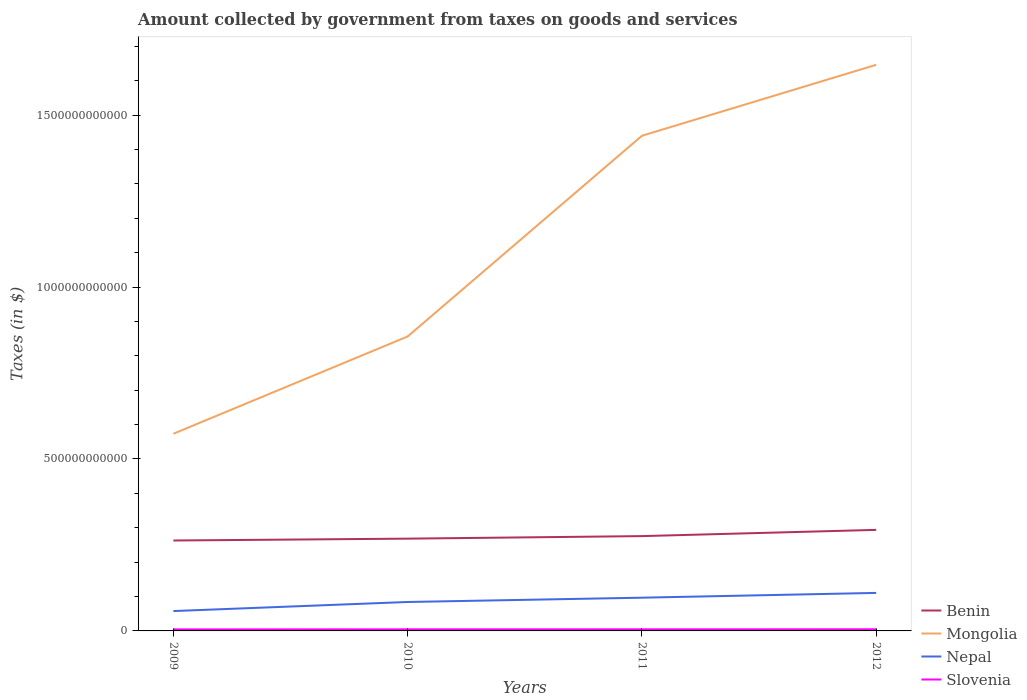Across all years, what is the maximum amount collected by government from taxes on goods and services in Benin?
Your response must be concise. 2.63e+11. What is the total amount collected by government from taxes on goods and services in Nepal in the graph?
Your response must be concise. -2.64e+1. What is the difference between the highest and the second highest amount collected by government from taxes on goods and services in Benin?
Make the answer very short. 3.09e+1. How many lines are there?
Ensure brevity in your answer.  4. What is the difference between two consecutive major ticks on the Y-axis?
Ensure brevity in your answer.  5.00e+11. Does the graph contain grids?
Your response must be concise. No. How many legend labels are there?
Ensure brevity in your answer.  4. What is the title of the graph?
Ensure brevity in your answer.  Amount collected by government from taxes on goods and services. What is the label or title of the Y-axis?
Your answer should be very brief. Taxes (in $). What is the Taxes (in $) in Benin in 2009?
Offer a very short reply. 2.63e+11. What is the Taxes (in $) of Mongolia in 2009?
Make the answer very short. 5.73e+11. What is the Taxes (in $) of Nepal in 2009?
Provide a short and direct response. 5.78e+1. What is the Taxes (in $) of Slovenia in 2009?
Your response must be concise. 4.54e+09. What is the Taxes (in $) in Benin in 2010?
Offer a very short reply. 2.68e+11. What is the Taxes (in $) of Mongolia in 2010?
Your response must be concise. 8.56e+11. What is the Taxes (in $) in Nepal in 2010?
Make the answer very short. 8.42e+1. What is the Taxes (in $) in Slovenia in 2010?
Make the answer very short. 4.66e+09. What is the Taxes (in $) of Benin in 2011?
Your answer should be compact. 2.76e+11. What is the Taxes (in $) of Mongolia in 2011?
Offer a terse response. 1.44e+12. What is the Taxes (in $) in Nepal in 2011?
Provide a succinct answer. 9.67e+1. What is the Taxes (in $) in Slovenia in 2011?
Keep it short and to the point. 4.73e+09. What is the Taxes (in $) of Benin in 2012?
Offer a terse response. 2.94e+11. What is the Taxes (in $) of Mongolia in 2012?
Offer a very short reply. 1.65e+12. What is the Taxes (in $) of Nepal in 2012?
Keep it short and to the point. 1.11e+11. What is the Taxes (in $) in Slovenia in 2012?
Your response must be concise. 4.76e+09. Across all years, what is the maximum Taxes (in $) of Benin?
Offer a very short reply. 2.94e+11. Across all years, what is the maximum Taxes (in $) in Mongolia?
Offer a very short reply. 1.65e+12. Across all years, what is the maximum Taxes (in $) of Nepal?
Ensure brevity in your answer.  1.11e+11. Across all years, what is the maximum Taxes (in $) of Slovenia?
Your answer should be compact. 4.76e+09. Across all years, what is the minimum Taxes (in $) of Benin?
Ensure brevity in your answer.  2.63e+11. Across all years, what is the minimum Taxes (in $) of Mongolia?
Provide a short and direct response. 5.73e+11. Across all years, what is the minimum Taxes (in $) in Nepal?
Offer a very short reply. 5.78e+1. Across all years, what is the minimum Taxes (in $) in Slovenia?
Make the answer very short. 4.54e+09. What is the total Taxes (in $) in Benin in the graph?
Ensure brevity in your answer.  1.10e+12. What is the total Taxes (in $) in Mongolia in the graph?
Ensure brevity in your answer.  4.52e+12. What is the total Taxes (in $) of Nepal in the graph?
Offer a very short reply. 3.49e+11. What is the total Taxes (in $) in Slovenia in the graph?
Keep it short and to the point. 1.87e+1. What is the difference between the Taxes (in $) in Benin in 2009 and that in 2010?
Offer a terse response. -5.42e+09. What is the difference between the Taxes (in $) of Mongolia in 2009 and that in 2010?
Your answer should be very brief. -2.83e+11. What is the difference between the Taxes (in $) in Nepal in 2009 and that in 2010?
Your answer should be compact. -2.64e+1. What is the difference between the Taxes (in $) of Slovenia in 2009 and that in 2010?
Your answer should be very brief. -1.17e+08. What is the difference between the Taxes (in $) of Benin in 2009 and that in 2011?
Your answer should be compact. -1.28e+1. What is the difference between the Taxes (in $) in Mongolia in 2009 and that in 2011?
Provide a short and direct response. -8.67e+11. What is the difference between the Taxes (in $) of Nepal in 2009 and that in 2011?
Ensure brevity in your answer.  -3.89e+1. What is the difference between the Taxes (in $) in Slovenia in 2009 and that in 2011?
Ensure brevity in your answer.  -1.91e+08. What is the difference between the Taxes (in $) in Benin in 2009 and that in 2012?
Your answer should be very brief. -3.09e+1. What is the difference between the Taxes (in $) of Mongolia in 2009 and that in 2012?
Offer a terse response. -1.07e+12. What is the difference between the Taxes (in $) in Nepal in 2009 and that in 2012?
Your response must be concise. -5.28e+1. What is the difference between the Taxes (in $) in Slovenia in 2009 and that in 2012?
Give a very brief answer. -2.20e+08. What is the difference between the Taxes (in $) in Benin in 2010 and that in 2011?
Keep it short and to the point. -7.35e+09. What is the difference between the Taxes (in $) in Mongolia in 2010 and that in 2011?
Provide a succinct answer. -5.84e+11. What is the difference between the Taxes (in $) of Nepal in 2010 and that in 2011?
Provide a succinct answer. -1.25e+1. What is the difference between the Taxes (in $) in Slovenia in 2010 and that in 2011?
Provide a succinct answer. -7.33e+07. What is the difference between the Taxes (in $) in Benin in 2010 and that in 2012?
Offer a very short reply. -2.55e+1. What is the difference between the Taxes (in $) of Mongolia in 2010 and that in 2012?
Provide a succinct answer. -7.90e+11. What is the difference between the Taxes (in $) in Nepal in 2010 and that in 2012?
Offer a terse response. -2.64e+1. What is the difference between the Taxes (in $) in Slovenia in 2010 and that in 2012?
Keep it short and to the point. -1.02e+08. What is the difference between the Taxes (in $) of Benin in 2011 and that in 2012?
Make the answer very short. -1.81e+1. What is the difference between the Taxes (in $) of Mongolia in 2011 and that in 2012?
Your response must be concise. -2.06e+11. What is the difference between the Taxes (in $) in Nepal in 2011 and that in 2012?
Offer a very short reply. -1.39e+1. What is the difference between the Taxes (in $) in Slovenia in 2011 and that in 2012?
Ensure brevity in your answer.  -2.91e+07. What is the difference between the Taxes (in $) of Benin in 2009 and the Taxes (in $) of Mongolia in 2010?
Keep it short and to the point. -5.93e+11. What is the difference between the Taxes (in $) of Benin in 2009 and the Taxes (in $) of Nepal in 2010?
Your answer should be very brief. 1.79e+11. What is the difference between the Taxes (in $) of Benin in 2009 and the Taxes (in $) of Slovenia in 2010?
Offer a terse response. 2.58e+11. What is the difference between the Taxes (in $) in Mongolia in 2009 and the Taxes (in $) in Nepal in 2010?
Offer a very short reply. 4.89e+11. What is the difference between the Taxes (in $) of Mongolia in 2009 and the Taxes (in $) of Slovenia in 2010?
Your answer should be compact. 5.69e+11. What is the difference between the Taxes (in $) of Nepal in 2009 and the Taxes (in $) of Slovenia in 2010?
Provide a succinct answer. 5.31e+1. What is the difference between the Taxes (in $) in Benin in 2009 and the Taxes (in $) in Mongolia in 2011?
Provide a succinct answer. -1.18e+12. What is the difference between the Taxes (in $) of Benin in 2009 and the Taxes (in $) of Nepal in 2011?
Your answer should be compact. 1.66e+11. What is the difference between the Taxes (in $) in Benin in 2009 and the Taxes (in $) in Slovenia in 2011?
Make the answer very short. 2.58e+11. What is the difference between the Taxes (in $) of Mongolia in 2009 and the Taxes (in $) of Nepal in 2011?
Offer a very short reply. 4.77e+11. What is the difference between the Taxes (in $) of Mongolia in 2009 and the Taxes (in $) of Slovenia in 2011?
Ensure brevity in your answer.  5.69e+11. What is the difference between the Taxes (in $) in Nepal in 2009 and the Taxes (in $) in Slovenia in 2011?
Offer a very short reply. 5.30e+1. What is the difference between the Taxes (in $) of Benin in 2009 and the Taxes (in $) of Mongolia in 2012?
Provide a short and direct response. -1.38e+12. What is the difference between the Taxes (in $) of Benin in 2009 and the Taxes (in $) of Nepal in 2012?
Ensure brevity in your answer.  1.52e+11. What is the difference between the Taxes (in $) in Benin in 2009 and the Taxes (in $) in Slovenia in 2012?
Give a very brief answer. 2.58e+11. What is the difference between the Taxes (in $) of Mongolia in 2009 and the Taxes (in $) of Nepal in 2012?
Your answer should be compact. 4.63e+11. What is the difference between the Taxes (in $) of Mongolia in 2009 and the Taxes (in $) of Slovenia in 2012?
Offer a very short reply. 5.69e+11. What is the difference between the Taxes (in $) in Nepal in 2009 and the Taxes (in $) in Slovenia in 2012?
Provide a succinct answer. 5.30e+1. What is the difference between the Taxes (in $) in Benin in 2010 and the Taxes (in $) in Mongolia in 2011?
Keep it short and to the point. -1.17e+12. What is the difference between the Taxes (in $) of Benin in 2010 and the Taxes (in $) of Nepal in 2011?
Provide a succinct answer. 1.72e+11. What is the difference between the Taxes (in $) in Benin in 2010 and the Taxes (in $) in Slovenia in 2011?
Provide a succinct answer. 2.64e+11. What is the difference between the Taxes (in $) of Mongolia in 2010 and the Taxes (in $) of Nepal in 2011?
Your response must be concise. 7.60e+11. What is the difference between the Taxes (in $) of Mongolia in 2010 and the Taxes (in $) of Slovenia in 2011?
Ensure brevity in your answer.  8.52e+11. What is the difference between the Taxes (in $) of Nepal in 2010 and the Taxes (in $) of Slovenia in 2011?
Ensure brevity in your answer.  7.94e+1. What is the difference between the Taxes (in $) of Benin in 2010 and the Taxes (in $) of Mongolia in 2012?
Offer a very short reply. -1.38e+12. What is the difference between the Taxes (in $) of Benin in 2010 and the Taxes (in $) of Nepal in 2012?
Keep it short and to the point. 1.58e+11. What is the difference between the Taxes (in $) of Benin in 2010 and the Taxes (in $) of Slovenia in 2012?
Offer a very short reply. 2.64e+11. What is the difference between the Taxes (in $) in Mongolia in 2010 and the Taxes (in $) in Nepal in 2012?
Keep it short and to the point. 7.46e+11. What is the difference between the Taxes (in $) of Mongolia in 2010 and the Taxes (in $) of Slovenia in 2012?
Your answer should be very brief. 8.52e+11. What is the difference between the Taxes (in $) in Nepal in 2010 and the Taxes (in $) in Slovenia in 2012?
Your response must be concise. 7.94e+1. What is the difference between the Taxes (in $) in Benin in 2011 and the Taxes (in $) in Mongolia in 2012?
Give a very brief answer. -1.37e+12. What is the difference between the Taxes (in $) of Benin in 2011 and the Taxes (in $) of Nepal in 2012?
Keep it short and to the point. 1.65e+11. What is the difference between the Taxes (in $) of Benin in 2011 and the Taxes (in $) of Slovenia in 2012?
Offer a very short reply. 2.71e+11. What is the difference between the Taxes (in $) in Mongolia in 2011 and the Taxes (in $) in Nepal in 2012?
Give a very brief answer. 1.33e+12. What is the difference between the Taxes (in $) of Mongolia in 2011 and the Taxes (in $) of Slovenia in 2012?
Keep it short and to the point. 1.44e+12. What is the difference between the Taxes (in $) in Nepal in 2011 and the Taxes (in $) in Slovenia in 2012?
Offer a terse response. 9.19e+1. What is the average Taxes (in $) of Benin per year?
Make the answer very short. 2.75e+11. What is the average Taxes (in $) in Mongolia per year?
Offer a very short reply. 1.13e+12. What is the average Taxes (in $) in Nepal per year?
Your answer should be compact. 8.73e+1. What is the average Taxes (in $) of Slovenia per year?
Provide a succinct answer. 4.67e+09. In the year 2009, what is the difference between the Taxes (in $) of Benin and Taxes (in $) of Mongolia?
Keep it short and to the point. -3.10e+11. In the year 2009, what is the difference between the Taxes (in $) in Benin and Taxes (in $) in Nepal?
Give a very brief answer. 2.05e+11. In the year 2009, what is the difference between the Taxes (in $) in Benin and Taxes (in $) in Slovenia?
Your response must be concise. 2.58e+11. In the year 2009, what is the difference between the Taxes (in $) in Mongolia and Taxes (in $) in Nepal?
Provide a succinct answer. 5.16e+11. In the year 2009, what is the difference between the Taxes (in $) in Mongolia and Taxes (in $) in Slovenia?
Offer a very short reply. 5.69e+11. In the year 2009, what is the difference between the Taxes (in $) of Nepal and Taxes (in $) of Slovenia?
Keep it short and to the point. 5.32e+1. In the year 2010, what is the difference between the Taxes (in $) in Benin and Taxes (in $) in Mongolia?
Provide a succinct answer. -5.88e+11. In the year 2010, what is the difference between the Taxes (in $) in Benin and Taxes (in $) in Nepal?
Your answer should be compact. 1.84e+11. In the year 2010, what is the difference between the Taxes (in $) of Benin and Taxes (in $) of Slovenia?
Offer a terse response. 2.64e+11. In the year 2010, what is the difference between the Taxes (in $) of Mongolia and Taxes (in $) of Nepal?
Offer a terse response. 7.72e+11. In the year 2010, what is the difference between the Taxes (in $) in Mongolia and Taxes (in $) in Slovenia?
Your answer should be compact. 8.52e+11. In the year 2010, what is the difference between the Taxes (in $) of Nepal and Taxes (in $) of Slovenia?
Give a very brief answer. 7.95e+1. In the year 2011, what is the difference between the Taxes (in $) in Benin and Taxes (in $) in Mongolia?
Offer a very short reply. -1.16e+12. In the year 2011, what is the difference between the Taxes (in $) of Benin and Taxes (in $) of Nepal?
Offer a very short reply. 1.79e+11. In the year 2011, what is the difference between the Taxes (in $) of Benin and Taxes (in $) of Slovenia?
Keep it short and to the point. 2.71e+11. In the year 2011, what is the difference between the Taxes (in $) in Mongolia and Taxes (in $) in Nepal?
Your answer should be compact. 1.34e+12. In the year 2011, what is the difference between the Taxes (in $) of Mongolia and Taxes (in $) of Slovenia?
Make the answer very short. 1.44e+12. In the year 2011, what is the difference between the Taxes (in $) of Nepal and Taxes (in $) of Slovenia?
Your answer should be compact. 9.19e+1. In the year 2012, what is the difference between the Taxes (in $) in Benin and Taxes (in $) in Mongolia?
Your response must be concise. -1.35e+12. In the year 2012, what is the difference between the Taxes (in $) of Benin and Taxes (in $) of Nepal?
Offer a very short reply. 1.83e+11. In the year 2012, what is the difference between the Taxes (in $) of Benin and Taxes (in $) of Slovenia?
Provide a short and direct response. 2.89e+11. In the year 2012, what is the difference between the Taxes (in $) in Mongolia and Taxes (in $) in Nepal?
Your response must be concise. 1.54e+12. In the year 2012, what is the difference between the Taxes (in $) in Mongolia and Taxes (in $) in Slovenia?
Offer a very short reply. 1.64e+12. In the year 2012, what is the difference between the Taxes (in $) in Nepal and Taxes (in $) in Slovenia?
Your answer should be compact. 1.06e+11. What is the ratio of the Taxes (in $) in Benin in 2009 to that in 2010?
Offer a terse response. 0.98. What is the ratio of the Taxes (in $) in Mongolia in 2009 to that in 2010?
Provide a succinct answer. 0.67. What is the ratio of the Taxes (in $) in Nepal in 2009 to that in 2010?
Your answer should be compact. 0.69. What is the ratio of the Taxes (in $) in Slovenia in 2009 to that in 2010?
Your answer should be very brief. 0.97. What is the ratio of the Taxes (in $) in Benin in 2009 to that in 2011?
Your answer should be compact. 0.95. What is the ratio of the Taxes (in $) in Mongolia in 2009 to that in 2011?
Your response must be concise. 0.4. What is the ratio of the Taxes (in $) of Nepal in 2009 to that in 2011?
Provide a succinct answer. 0.6. What is the ratio of the Taxes (in $) in Slovenia in 2009 to that in 2011?
Offer a very short reply. 0.96. What is the ratio of the Taxes (in $) of Benin in 2009 to that in 2012?
Your answer should be very brief. 0.89. What is the ratio of the Taxes (in $) in Mongolia in 2009 to that in 2012?
Ensure brevity in your answer.  0.35. What is the ratio of the Taxes (in $) of Nepal in 2009 to that in 2012?
Your answer should be compact. 0.52. What is the ratio of the Taxes (in $) of Slovenia in 2009 to that in 2012?
Your answer should be compact. 0.95. What is the ratio of the Taxes (in $) of Benin in 2010 to that in 2011?
Keep it short and to the point. 0.97. What is the ratio of the Taxes (in $) of Mongolia in 2010 to that in 2011?
Offer a terse response. 0.59. What is the ratio of the Taxes (in $) in Nepal in 2010 to that in 2011?
Provide a succinct answer. 0.87. What is the ratio of the Taxes (in $) of Slovenia in 2010 to that in 2011?
Make the answer very short. 0.98. What is the ratio of the Taxes (in $) of Benin in 2010 to that in 2012?
Offer a terse response. 0.91. What is the ratio of the Taxes (in $) in Mongolia in 2010 to that in 2012?
Give a very brief answer. 0.52. What is the ratio of the Taxes (in $) in Nepal in 2010 to that in 2012?
Provide a short and direct response. 0.76. What is the ratio of the Taxes (in $) in Slovenia in 2010 to that in 2012?
Provide a short and direct response. 0.98. What is the ratio of the Taxes (in $) in Benin in 2011 to that in 2012?
Make the answer very short. 0.94. What is the ratio of the Taxes (in $) of Mongolia in 2011 to that in 2012?
Provide a short and direct response. 0.87. What is the ratio of the Taxes (in $) of Nepal in 2011 to that in 2012?
Offer a terse response. 0.87. What is the difference between the highest and the second highest Taxes (in $) in Benin?
Give a very brief answer. 1.81e+1. What is the difference between the highest and the second highest Taxes (in $) in Mongolia?
Your answer should be compact. 2.06e+11. What is the difference between the highest and the second highest Taxes (in $) in Nepal?
Your answer should be compact. 1.39e+1. What is the difference between the highest and the second highest Taxes (in $) of Slovenia?
Provide a succinct answer. 2.91e+07. What is the difference between the highest and the lowest Taxes (in $) of Benin?
Give a very brief answer. 3.09e+1. What is the difference between the highest and the lowest Taxes (in $) of Mongolia?
Give a very brief answer. 1.07e+12. What is the difference between the highest and the lowest Taxes (in $) in Nepal?
Your response must be concise. 5.28e+1. What is the difference between the highest and the lowest Taxes (in $) in Slovenia?
Keep it short and to the point. 2.20e+08. 